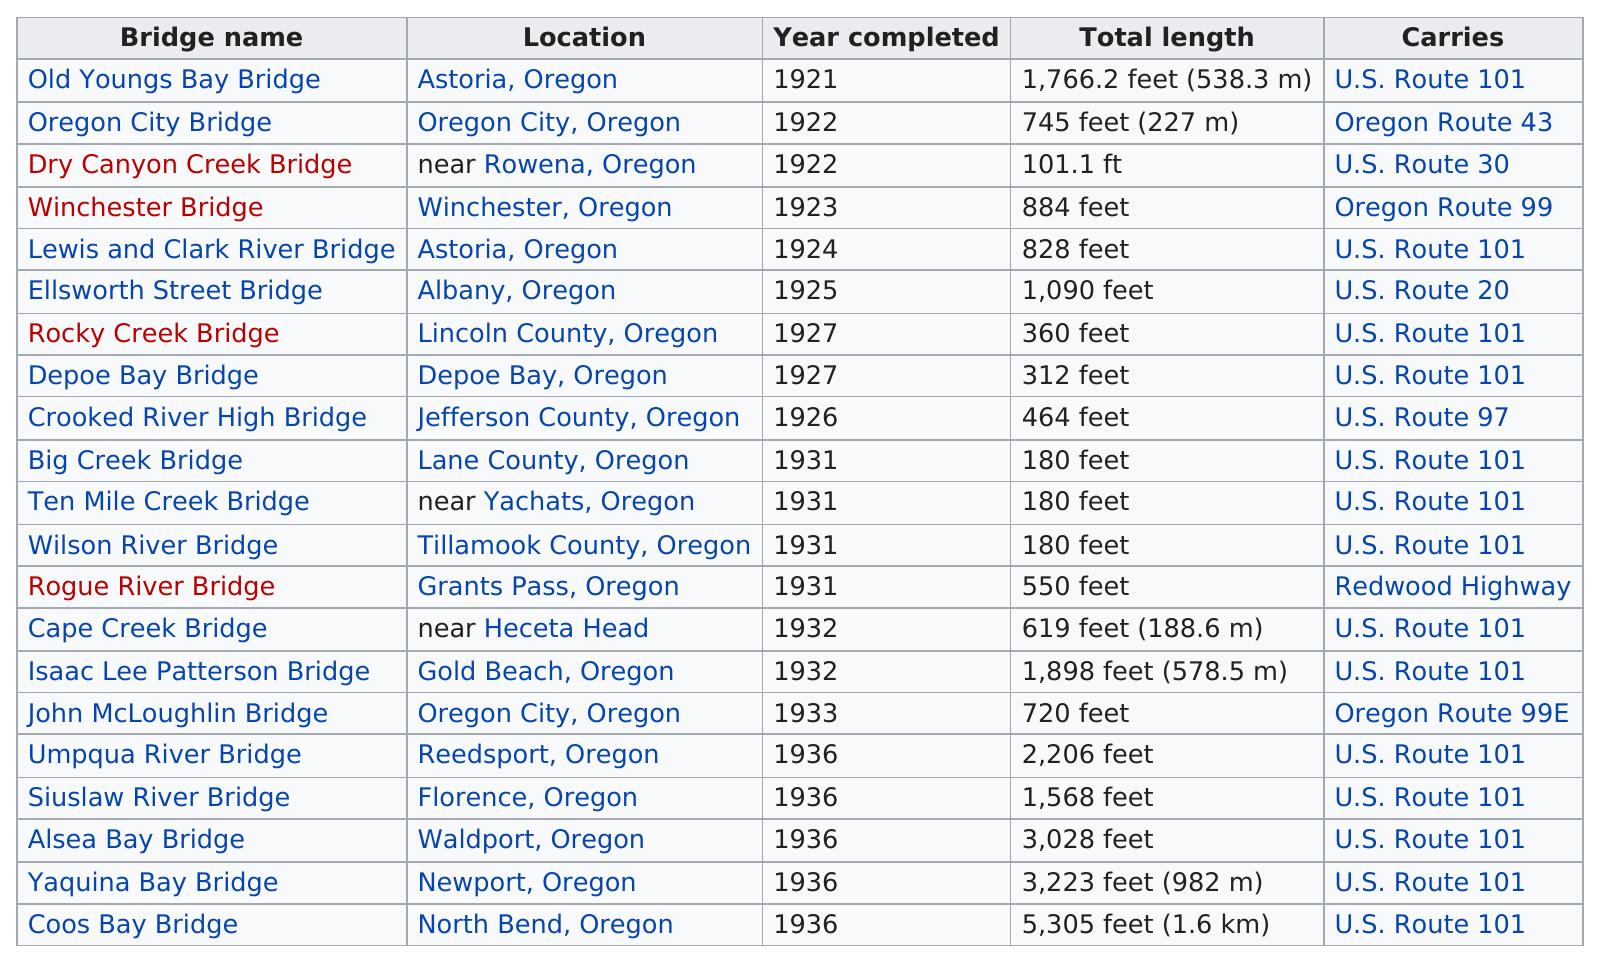Identify some key points in this picture. The average length of a bridge built in 1927 was 336 feet, as stated in a record of such a bridge. The Old Youngs Bay Bridge, built in the 1920s, was the first bridge to be constructed in that decade. In 1931, a total of 4 bridges were constructed. There are seven bridges that are over 1,000 feet long and also carry U.S. Route 101 in the United States. The Old Youngs Bay Bridge is longer than the Oregon City Bridge. 